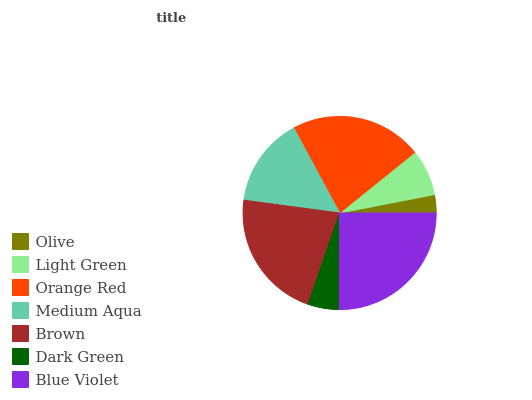Is Olive the minimum?
Answer yes or no. Yes. Is Blue Violet the maximum?
Answer yes or no. Yes. Is Light Green the minimum?
Answer yes or no. No. Is Light Green the maximum?
Answer yes or no. No. Is Light Green greater than Olive?
Answer yes or no. Yes. Is Olive less than Light Green?
Answer yes or no. Yes. Is Olive greater than Light Green?
Answer yes or no. No. Is Light Green less than Olive?
Answer yes or no. No. Is Medium Aqua the high median?
Answer yes or no. Yes. Is Medium Aqua the low median?
Answer yes or no. Yes. Is Blue Violet the high median?
Answer yes or no. No. Is Light Green the low median?
Answer yes or no. No. 